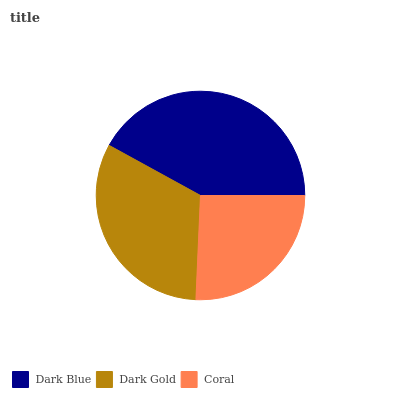Is Coral the minimum?
Answer yes or no. Yes. Is Dark Blue the maximum?
Answer yes or no. Yes. Is Dark Gold the minimum?
Answer yes or no. No. Is Dark Gold the maximum?
Answer yes or no. No. Is Dark Blue greater than Dark Gold?
Answer yes or no. Yes. Is Dark Gold less than Dark Blue?
Answer yes or no. Yes. Is Dark Gold greater than Dark Blue?
Answer yes or no. No. Is Dark Blue less than Dark Gold?
Answer yes or no. No. Is Dark Gold the high median?
Answer yes or no. Yes. Is Dark Gold the low median?
Answer yes or no. Yes. Is Coral the high median?
Answer yes or no. No. Is Coral the low median?
Answer yes or no. No. 